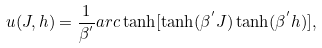Convert formula to latex. <formula><loc_0><loc_0><loc_500><loc_500>u ( J , h ) = \frac { 1 } { \beta ^ { ^ { \prime } } } a r c \tanh [ \tanh ( \beta ^ { ^ { \prime } } J ) \tanh ( \beta ^ { ^ { \prime } } h ) ] ,</formula> 